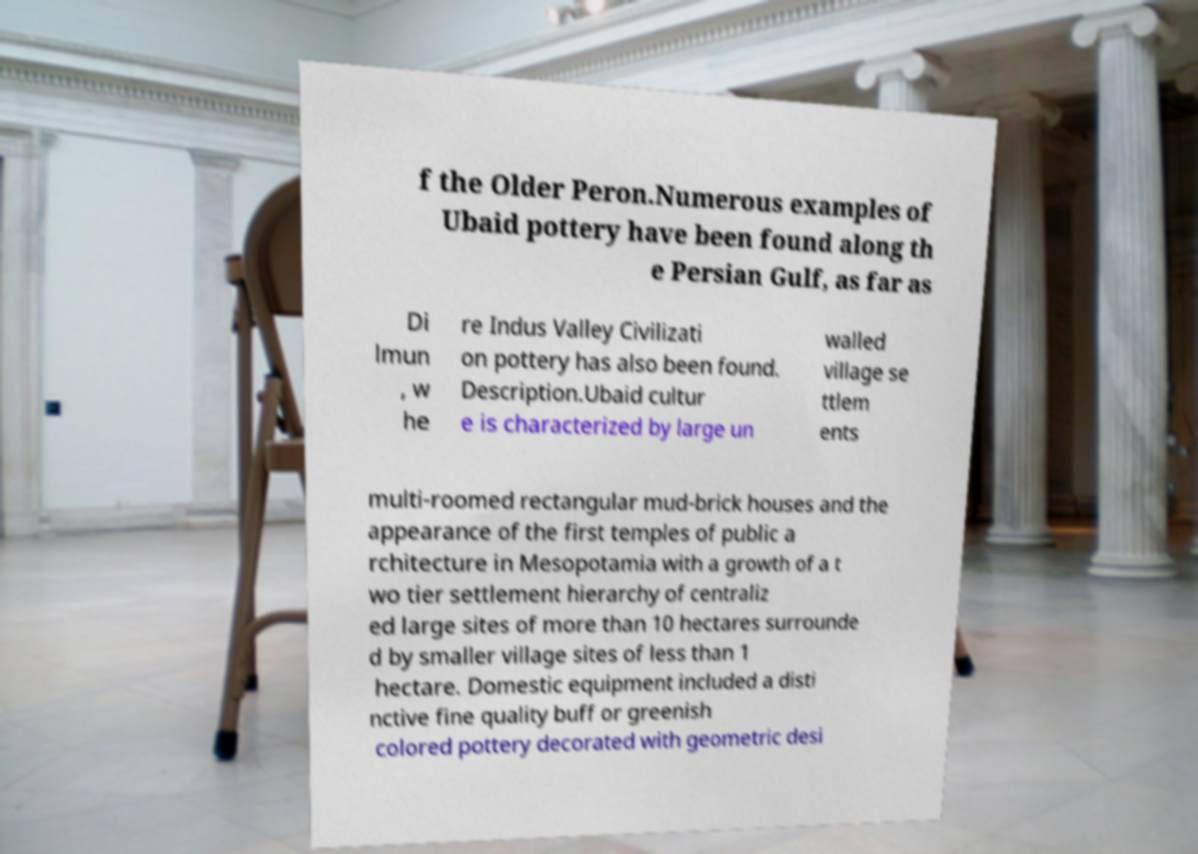Can you read and provide the text displayed in the image?This photo seems to have some interesting text. Can you extract and type it out for me? f the Older Peron.Numerous examples of Ubaid pottery have been found along th e Persian Gulf, as far as Di lmun , w he re Indus Valley Civilizati on pottery has also been found. Description.Ubaid cultur e is characterized by large un walled village se ttlem ents multi-roomed rectangular mud-brick houses and the appearance of the first temples of public a rchitecture in Mesopotamia with a growth of a t wo tier settlement hierarchy of centraliz ed large sites of more than 10 hectares surrounde d by smaller village sites of less than 1 hectare. Domestic equipment included a disti nctive fine quality buff or greenish colored pottery decorated with geometric desi 